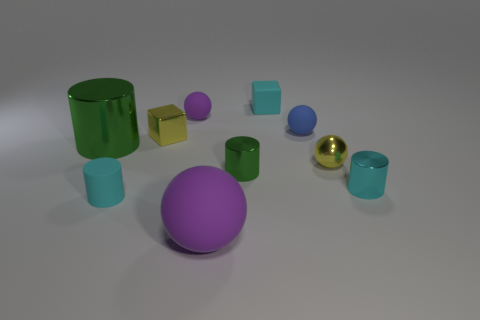Subtract all small spheres. How many spheres are left? 1 Subtract 2 balls. How many balls are left? 2 Subtract all spheres. How many objects are left? 6 Subtract all yellow blocks. Subtract all cyan spheres. How many blocks are left? 1 Subtract all blue cylinders. How many yellow spheres are left? 1 Subtract all blue matte spheres. Subtract all tiny metal cylinders. How many objects are left? 7 Add 2 purple matte objects. How many purple matte objects are left? 4 Add 7 blue objects. How many blue objects exist? 8 Subtract all blue spheres. How many spheres are left? 3 Subtract 0 brown balls. How many objects are left? 10 